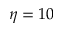Convert formula to latex. <formula><loc_0><loc_0><loc_500><loc_500>\eta = 1 0</formula> 